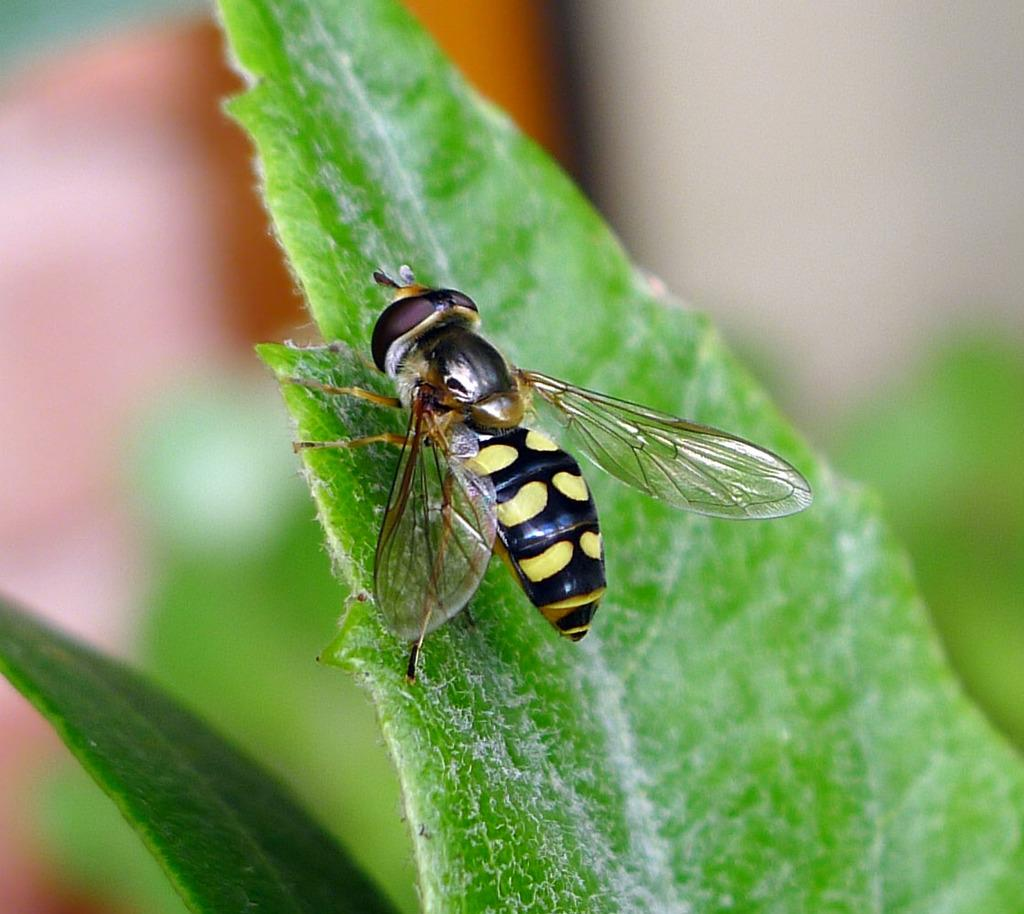What is the main subject of the image? There is a bee in the image. Where is the bee located? The bee is on a leaf. Can you describe the background of the image? The background of the image is blurred. How does the bee interact with the pie in the image? There is no pie present in the image, so the bee cannot interact with it. 